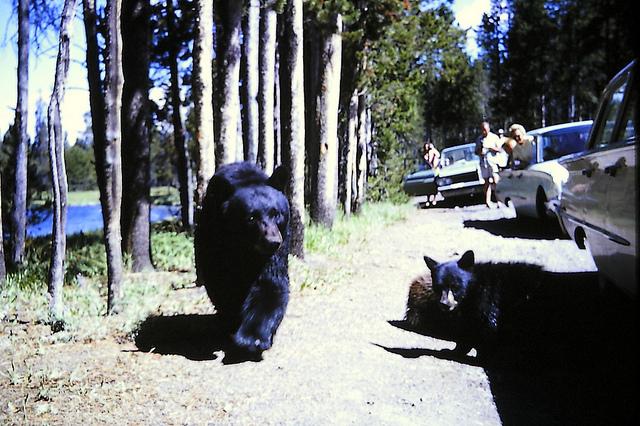Is this a modern day photo?
Answer briefly. No. What animals do you see?
Keep it brief. Bears. Can the people pet these animals?
Give a very brief answer. No. 